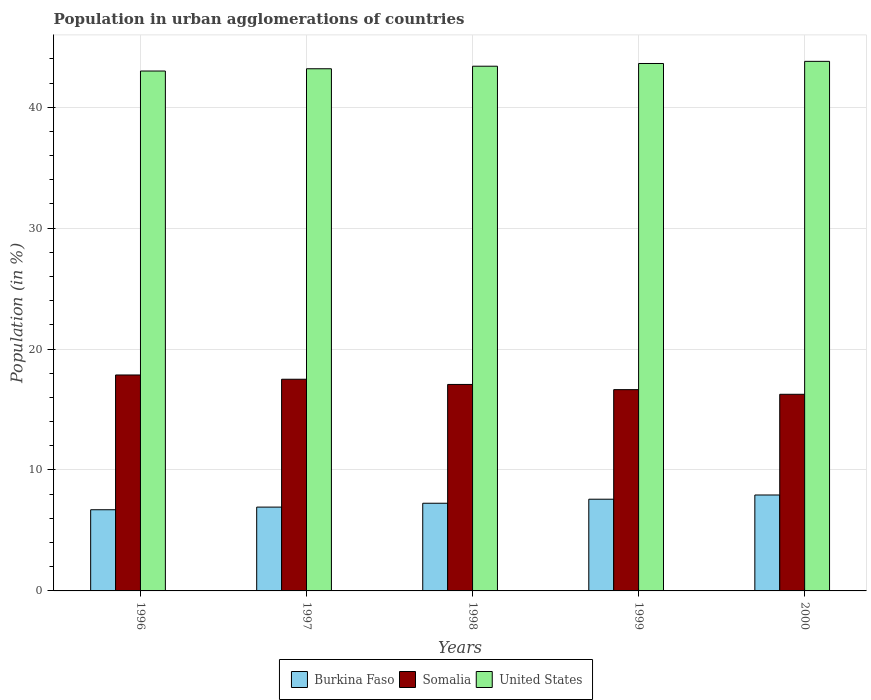How many different coloured bars are there?
Offer a very short reply. 3. Are the number of bars on each tick of the X-axis equal?
Make the answer very short. Yes. What is the percentage of population in urban agglomerations in Burkina Faso in 1997?
Offer a very short reply. 6.93. Across all years, what is the maximum percentage of population in urban agglomerations in Burkina Faso?
Provide a succinct answer. 7.93. Across all years, what is the minimum percentage of population in urban agglomerations in Somalia?
Your answer should be compact. 16.26. In which year was the percentage of population in urban agglomerations in United States maximum?
Your answer should be very brief. 2000. In which year was the percentage of population in urban agglomerations in United States minimum?
Give a very brief answer. 1996. What is the total percentage of population in urban agglomerations in Somalia in the graph?
Offer a terse response. 85.34. What is the difference between the percentage of population in urban agglomerations in Burkina Faso in 1998 and that in 2000?
Give a very brief answer. -0.68. What is the difference between the percentage of population in urban agglomerations in Somalia in 2000 and the percentage of population in urban agglomerations in United States in 1998?
Provide a short and direct response. -27.13. What is the average percentage of population in urban agglomerations in Somalia per year?
Your answer should be very brief. 17.07. In the year 2000, what is the difference between the percentage of population in urban agglomerations in Burkina Faso and percentage of population in urban agglomerations in Somalia?
Your answer should be compact. -8.33. What is the ratio of the percentage of population in urban agglomerations in United States in 1998 to that in 1999?
Keep it short and to the point. 0.99. Is the percentage of population in urban agglomerations in United States in 1998 less than that in 1999?
Provide a succinct answer. Yes. What is the difference between the highest and the second highest percentage of population in urban agglomerations in United States?
Your response must be concise. 0.18. What is the difference between the highest and the lowest percentage of population in urban agglomerations in Somalia?
Ensure brevity in your answer.  1.6. In how many years, is the percentage of population in urban agglomerations in Somalia greater than the average percentage of population in urban agglomerations in Somalia taken over all years?
Your answer should be compact. 3. Is the sum of the percentage of population in urban agglomerations in United States in 1999 and 2000 greater than the maximum percentage of population in urban agglomerations in Somalia across all years?
Your answer should be very brief. Yes. What does the 1st bar from the left in 2000 represents?
Ensure brevity in your answer.  Burkina Faso. What does the 3rd bar from the right in 1999 represents?
Keep it short and to the point. Burkina Faso. Is it the case that in every year, the sum of the percentage of population in urban agglomerations in Somalia and percentage of population in urban agglomerations in United States is greater than the percentage of population in urban agglomerations in Burkina Faso?
Ensure brevity in your answer.  Yes. How many bars are there?
Give a very brief answer. 15. Are all the bars in the graph horizontal?
Provide a short and direct response. No. How many years are there in the graph?
Your answer should be compact. 5. Are the values on the major ticks of Y-axis written in scientific E-notation?
Keep it short and to the point. No. Does the graph contain any zero values?
Offer a very short reply. No. Where does the legend appear in the graph?
Provide a short and direct response. Bottom center. What is the title of the graph?
Your answer should be compact. Population in urban agglomerations of countries. What is the label or title of the X-axis?
Provide a succinct answer. Years. What is the label or title of the Y-axis?
Your answer should be compact. Population (in %). What is the Population (in %) in Burkina Faso in 1996?
Your response must be concise. 6.71. What is the Population (in %) in Somalia in 1996?
Give a very brief answer. 17.86. What is the Population (in %) in United States in 1996?
Provide a short and direct response. 42.99. What is the Population (in %) of Burkina Faso in 1997?
Offer a very short reply. 6.93. What is the Population (in %) of Somalia in 1997?
Ensure brevity in your answer.  17.5. What is the Population (in %) of United States in 1997?
Your answer should be very brief. 43.18. What is the Population (in %) in Burkina Faso in 1998?
Give a very brief answer. 7.25. What is the Population (in %) of Somalia in 1998?
Offer a terse response. 17.07. What is the Population (in %) in United States in 1998?
Give a very brief answer. 43.39. What is the Population (in %) in Burkina Faso in 1999?
Keep it short and to the point. 7.58. What is the Population (in %) in Somalia in 1999?
Your answer should be very brief. 16.64. What is the Population (in %) of United States in 1999?
Provide a short and direct response. 43.61. What is the Population (in %) in Burkina Faso in 2000?
Give a very brief answer. 7.93. What is the Population (in %) of Somalia in 2000?
Your answer should be very brief. 16.26. What is the Population (in %) in United States in 2000?
Ensure brevity in your answer.  43.79. Across all years, what is the maximum Population (in %) of Burkina Faso?
Offer a very short reply. 7.93. Across all years, what is the maximum Population (in %) in Somalia?
Make the answer very short. 17.86. Across all years, what is the maximum Population (in %) of United States?
Offer a terse response. 43.79. Across all years, what is the minimum Population (in %) in Burkina Faso?
Offer a terse response. 6.71. Across all years, what is the minimum Population (in %) of Somalia?
Give a very brief answer. 16.26. Across all years, what is the minimum Population (in %) of United States?
Provide a short and direct response. 42.99. What is the total Population (in %) in Burkina Faso in the graph?
Provide a short and direct response. 36.41. What is the total Population (in %) in Somalia in the graph?
Ensure brevity in your answer.  85.34. What is the total Population (in %) in United States in the graph?
Keep it short and to the point. 216.97. What is the difference between the Population (in %) in Burkina Faso in 1996 and that in 1997?
Your answer should be very brief. -0.22. What is the difference between the Population (in %) of Somalia in 1996 and that in 1997?
Ensure brevity in your answer.  0.35. What is the difference between the Population (in %) in United States in 1996 and that in 1997?
Offer a very short reply. -0.19. What is the difference between the Population (in %) in Burkina Faso in 1996 and that in 1998?
Your answer should be compact. -0.54. What is the difference between the Population (in %) of Somalia in 1996 and that in 1998?
Your answer should be compact. 0.78. What is the difference between the Population (in %) of United States in 1996 and that in 1998?
Give a very brief answer. -0.4. What is the difference between the Population (in %) of Burkina Faso in 1996 and that in 1999?
Your answer should be compact. -0.87. What is the difference between the Population (in %) in Somalia in 1996 and that in 1999?
Ensure brevity in your answer.  1.21. What is the difference between the Population (in %) in United States in 1996 and that in 1999?
Your response must be concise. -0.62. What is the difference between the Population (in %) in Burkina Faso in 1996 and that in 2000?
Provide a short and direct response. -1.22. What is the difference between the Population (in %) of Somalia in 1996 and that in 2000?
Make the answer very short. 1.6. What is the difference between the Population (in %) in United States in 1996 and that in 2000?
Ensure brevity in your answer.  -0.8. What is the difference between the Population (in %) in Burkina Faso in 1997 and that in 1998?
Your response must be concise. -0.32. What is the difference between the Population (in %) in Somalia in 1997 and that in 1998?
Your response must be concise. 0.43. What is the difference between the Population (in %) of United States in 1997 and that in 1998?
Offer a very short reply. -0.21. What is the difference between the Population (in %) of Burkina Faso in 1997 and that in 1999?
Offer a terse response. -0.65. What is the difference between the Population (in %) of Somalia in 1997 and that in 1999?
Provide a succinct answer. 0.86. What is the difference between the Population (in %) in United States in 1997 and that in 1999?
Give a very brief answer. -0.44. What is the difference between the Population (in %) in Burkina Faso in 1997 and that in 2000?
Make the answer very short. -1. What is the difference between the Population (in %) in Somalia in 1997 and that in 2000?
Offer a terse response. 1.24. What is the difference between the Population (in %) in United States in 1997 and that in 2000?
Give a very brief answer. -0.61. What is the difference between the Population (in %) in Burkina Faso in 1998 and that in 1999?
Give a very brief answer. -0.33. What is the difference between the Population (in %) in Somalia in 1998 and that in 1999?
Give a very brief answer. 0.43. What is the difference between the Population (in %) in United States in 1998 and that in 1999?
Keep it short and to the point. -0.23. What is the difference between the Population (in %) of Burkina Faso in 1998 and that in 2000?
Offer a terse response. -0.68. What is the difference between the Population (in %) in Somalia in 1998 and that in 2000?
Provide a short and direct response. 0.81. What is the difference between the Population (in %) in United States in 1998 and that in 2000?
Your answer should be very brief. -0.4. What is the difference between the Population (in %) in Burkina Faso in 1999 and that in 2000?
Provide a short and direct response. -0.35. What is the difference between the Population (in %) of Somalia in 1999 and that in 2000?
Keep it short and to the point. 0.38. What is the difference between the Population (in %) in United States in 1999 and that in 2000?
Ensure brevity in your answer.  -0.18. What is the difference between the Population (in %) in Burkina Faso in 1996 and the Population (in %) in Somalia in 1997?
Give a very brief answer. -10.79. What is the difference between the Population (in %) of Burkina Faso in 1996 and the Population (in %) of United States in 1997?
Give a very brief answer. -36.47. What is the difference between the Population (in %) in Somalia in 1996 and the Population (in %) in United States in 1997?
Provide a short and direct response. -25.32. What is the difference between the Population (in %) of Burkina Faso in 1996 and the Population (in %) of Somalia in 1998?
Give a very brief answer. -10.36. What is the difference between the Population (in %) of Burkina Faso in 1996 and the Population (in %) of United States in 1998?
Keep it short and to the point. -36.68. What is the difference between the Population (in %) in Somalia in 1996 and the Population (in %) in United States in 1998?
Your response must be concise. -25.53. What is the difference between the Population (in %) in Burkina Faso in 1996 and the Population (in %) in Somalia in 1999?
Ensure brevity in your answer.  -9.93. What is the difference between the Population (in %) in Burkina Faso in 1996 and the Population (in %) in United States in 1999?
Offer a very short reply. -36.9. What is the difference between the Population (in %) of Somalia in 1996 and the Population (in %) of United States in 1999?
Your answer should be compact. -25.76. What is the difference between the Population (in %) of Burkina Faso in 1996 and the Population (in %) of Somalia in 2000?
Make the answer very short. -9.55. What is the difference between the Population (in %) in Burkina Faso in 1996 and the Population (in %) in United States in 2000?
Make the answer very short. -37.08. What is the difference between the Population (in %) in Somalia in 1996 and the Population (in %) in United States in 2000?
Provide a succinct answer. -25.93. What is the difference between the Population (in %) in Burkina Faso in 1997 and the Population (in %) in Somalia in 1998?
Provide a succinct answer. -10.14. What is the difference between the Population (in %) of Burkina Faso in 1997 and the Population (in %) of United States in 1998?
Give a very brief answer. -36.46. What is the difference between the Population (in %) in Somalia in 1997 and the Population (in %) in United States in 1998?
Provide a short and direct response. -25.89. What is the difference between the Population (in %) of Burkina Faso in 1997 and the Population (in %) of Somalia in 1999?
Your response must be concise. -9.71. What is the difference between the Population (in %) in Burkina Faso in 1997 and the Population (in %) in United States in 1999?
Ensure brevity in your answer.  -36.68. What is the difference between the Population (in %) of Somalia in 1997 and the Population (in %) of United States in 1999?
Make the answer very short. -26.11. What is the difference between the Population (in %) of Burkina Faso in 1997 and the Population (in %) of Somalia in 2000?
Provide a short and direct response. -9.33. What is the difference between the Population (in %) in Burkina Faso in 1997 and the Population (in %) in United States in 2000?
Provide a short and direct response. -36.86. What is the difference between the Population (in %) of Somalia in 1997 and the Population (in %) of United States in 2000?
Ensure brevity in your answer.  -26.29. What is the difference between the Population (in %) in Burkina Faso in 1998 and the Population (in %) in Somalia in 1999?
Offer a terse response. -9.39. What is the difference between the Population (in %) in Burkina Faso in 1998 and the Population (in %) in United States in 1999?
Your answer should be very brief. -36.36. What is the difference between the Population (in %) of Somalia in 1998 and the Population (in %) of United States in 1999?
Offer a very short reply. -26.54. What is the difference between the Population (in %) in Burkina Faso in 1998 and the Population (in %) in Somalia in 2000?
Offer a terse response. -9.01. What is the difference between the Population (in %) of Burkina Faso in 1998 and the Population (in %) of United States in 2000?
Give a very brief answer. -36.54. What is the difference between the Population (in %) of Somalia in 1998 and the Population (in %) of United States in 2000?
Offer a very short reply. -26.72. What is the difference between the Population (in %) in Burkina Faso in 1999 and the Population (in %) in Somalia in 2000?
Offer a very short reply. -8.68. What is the difference between the Population (in %) in Burkina Faso in 1999 and the Population (in %) in United States in 2000?
Provide a short and direct response. -36.21. What is the difference between the Population (in %) of Somalia in 1999 and the Population (in %) of United States in 2000?
Your response must be concise. -27.15. What is the average Population (in %) in Burkina Faso per year?
Your answer should be compact. 7.28. What is the average Population (in %) in Somalia per year?
Ensure brevity in your answer.  17.07. What is the average Population (in %) of United States per year?
Keep it short and to the point. 43.39. In the year 1996, what is the difference between the Population (in %) of Burkina Faso and Population (in %) of Somalia?
Ensure brevity in your answer.  -11.14. In the year 1996, what is the difference between the Population (in %) in Burkina Faso and Population (in %) in United States?
Provide a succinct answer. -36.28. In the year 1996, what is the difference between the Population (in %) of Somalia and Population (in %) of United States?
Offer a very short reply. -25.13. In the year 1997, what is the difference between the Population (in %) in Burkina Faso and Population (in %) in Somalia?
Your answer should be compact. -10.57. In the year 1997, what is the difference between the Population (in %) in Burkina Faso and Population (in %) in United States?
Your response must be concise. -36.25. In the year 1997, what is the difference between the Population (in %) of Somalia and Population (in %) of United States?
Keep it short and to the point. -25.67. In the year 1998, what is the difference between the Population (in %) of Burkina Faso and Population (in %) of Somalia?
Provide a short and direct response. -9.82. In the year 1998, what is the difference between the Population (in %) of Burkina Faso and Population (in %) of United States?
Provide a succinct answer. -36.14. In the year 1998, what is the difference between the Population (in %) in Somalia and Population (in %) in United States?
Offer a terse response. -26.32. In the year 1999, what is the difference between the Population (in %) in Burkina Faso and Population (in %) in Somalia?
Ensure brevity in your answer.  -9.06. In the year 1999, what is the difference between the Population (in %) of Burkina Faso and Population (in %) of United States?
Your answer should be compact. -36.03. In the year 1999, what is the difference between the Population (in %) in Somalia and Population (in %) in United States?
Your response must be concise. -26.97. In the year 2000, what is the difference between the Population (in %) in Burkina Faso and Population (in %) in Somalia?
Keep it short and to the point. -8.33. In the year 2000, what is the difference between the Population (in %) of Burkina Faso and Population (in %) of United States?
Offer a terse response. -35.86. In the year 2000, what is the difference between the Population (in %) in Somalia and Population (in %) in United States?
Your answer should be compact. -27.53. What is the ratio of the Population (in %) in Burkina Faso in 1996 to that in 1997?
Your answer should be very brief. 0.97. What is the ratio of the Population (in %) of Somalia in 1996 to that in 1997?
Your answer should be compact. 1.02. What is the ratio of the Population (in %) of United States in 1996 to that in 1997?
Your response must be concise. 1. What is the ratio of the Population (in %) in Burkina Faso in 1996 to that in 1998?
Your answer should be compact. 0.93. What is the ratio of the Population (in %) of Somalia in 1996 to that in 1998?
Your response must be concise. 1.05. What is the ratio of the Population (in %) in United States in 1996 to that in 1998?
Offer a very short reply. 0.99. What is the ratio of the Population (in %) in Burkina Faso in 1996 to that in 1999?
Provide a succinct answer. 0.89. What is the ratio of the Population (in %) in Somalia in 1996 to that in 1999?
Your answer should be very brief. 1.07. What is the ratio of the Population (in %) in United States in 1996 to that in 1999?
Your answer should be compact. 0.99. What is the ratio of the Population (in %) in Burkina Faso in 1996 to that in 2000?
Provide a short and direct response. 0.85. What is the ratio of the Population (in %) of Somalia in 1996 to that in 2000?
Your answer should be very brief. 1.1. What is the ratio of the Population (in %) of United States in 1996 to that in 2000?
Offer a very short reply. 0.98. What is the ratio of the Population (in %) in Burkina Faso in 1997 to that in 1998?
Your response must be concise. 0.96. What is the ratio of the Population (in %) of Somalia in 1997 to that in 1998?
Offer a terse response. 1.03. What is the ratio of the Population (in %) of United States in 1997 to that in 1998?
Your answer should be compact. 1. What is the ratio of the Population (in %) of Burkina Faso in 1997 to that in 1999?
Make the answer very short. 0.91. What is the ratio of the Population (in %) of Somalia in 1997 to that in 1999?
Your answer should be very brief. 1.05. What is the ratio of the Population (in %) of United States in 1997 to that in 1999?
Offer a very short reply. 0.99. What is the ratio of the Population (in %) of Burkina Faso in 1997 to that in 2000?
Your answer should be very brief. 0.87. What is the ratio of the Population (in %) in Somalia in 1997 to that in 2000?
Make the answer very short. 1.08. What is the ratio of the Population (in %) of United States in 1997 to that in 2000?
Your response must be concise. 0.99. What is the ratio of the Population (in %) in Burkina Faso in 1998 to that in 1999?
Ensure brevity in your answer.  0.96. What is the ratio of the Population (in %) in Somalia in 1998 to that in 1999?
Keep it short and to the point. 1.03. What is the ratio of the Population (in %) in United States in 1998 to that in 1999?
Your answer should be compact. 0.99. What is the ratio of the Population (in %) in Burkina Faso in 1998 to that in 2000?
Your response must be concise. 0.91. What is the ratio of the Population (in %) in Somalia in 1998 to that in 2000?
Keep it short and to the point. 1.05. What is the ratio of the Population (in %) of Burkina Faso in 1999 to that in 2000?
Ensure brevity in your answer.  0.96. What is the ratio of the Population (in %) in Somalia in 1999 to that in 2000?
Your response must be concise. 1.02. What is the ratio of the Population (in %) in United States in 1999 to that in 2000?
Offer a terse response. 1. What is the difference between the highest and the second highest Population (in %) in Burkina Faso?
Your response must be concise. 0.35. What is the difference between the highest and the second highest Population (in %) of Somalia?
Your response must be concise. 0.35. What is the difference between the highest and the second highest Population (in %) in United States?
Offer a very short reply. 0.18. What is the difference between the highest and the lowest Population (in %) in Burkina Faso?
Make the answer very short. 1.22. What is the difference between the highest and the lowest Population (in %) of Somalia?
Offer a terse response. 1.6. What is the difference between the highest and the lowest Population (in %) of United States?
Give a very brief answer. 0.8. 